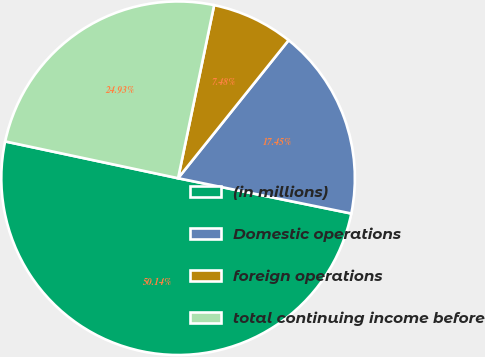<chart> <loc_0><loc_0><loc_500><loc_500><pie_chart><fcel>(in millions)<fcel>Domestic operations<fcel>foreign operations<fcel>total continuing income before<nl><fcel>50.14%<fcel>17.45%<fcel>7.48%<fcel>24.93%<nl></chart> 